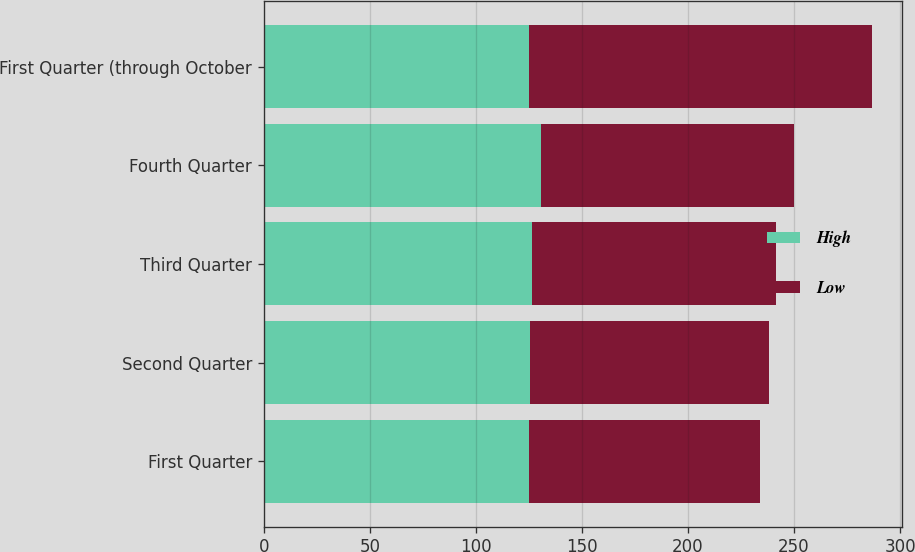Convert chart. <chart><loc_0><loc_0><loc_500><loc_500><stacked_bar_chart><ecel><fcel>First Quarter<fcel>Second Quarter<fcel>Third Quarter<fcel>Fourth Quarter<fcel>First Quarter (through October<nl><fcel>High<fcel>124.96<fcel>125.72<fcel>126.53<fcel>130.92<fcel>124.96<nl><fcel>Low<fcel>108.83<fcel>112.31<fcel>114.82<fcel>119.1<fcel>161.58<nl></chart> 